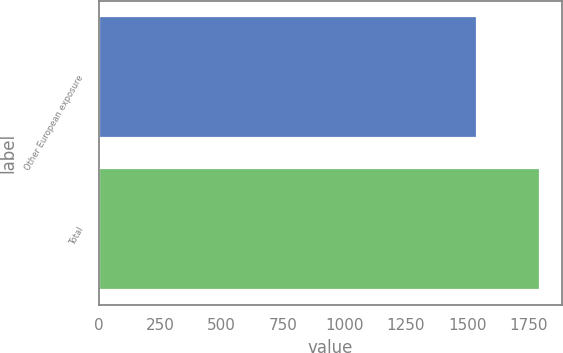Convert chart. <chart><loc_0><loc_0><loc_500><loc_500><bar_chart><fcel>Other European exposure<fcel>Total<nl><fcel>1540<fcel>1795<nl></chart> 